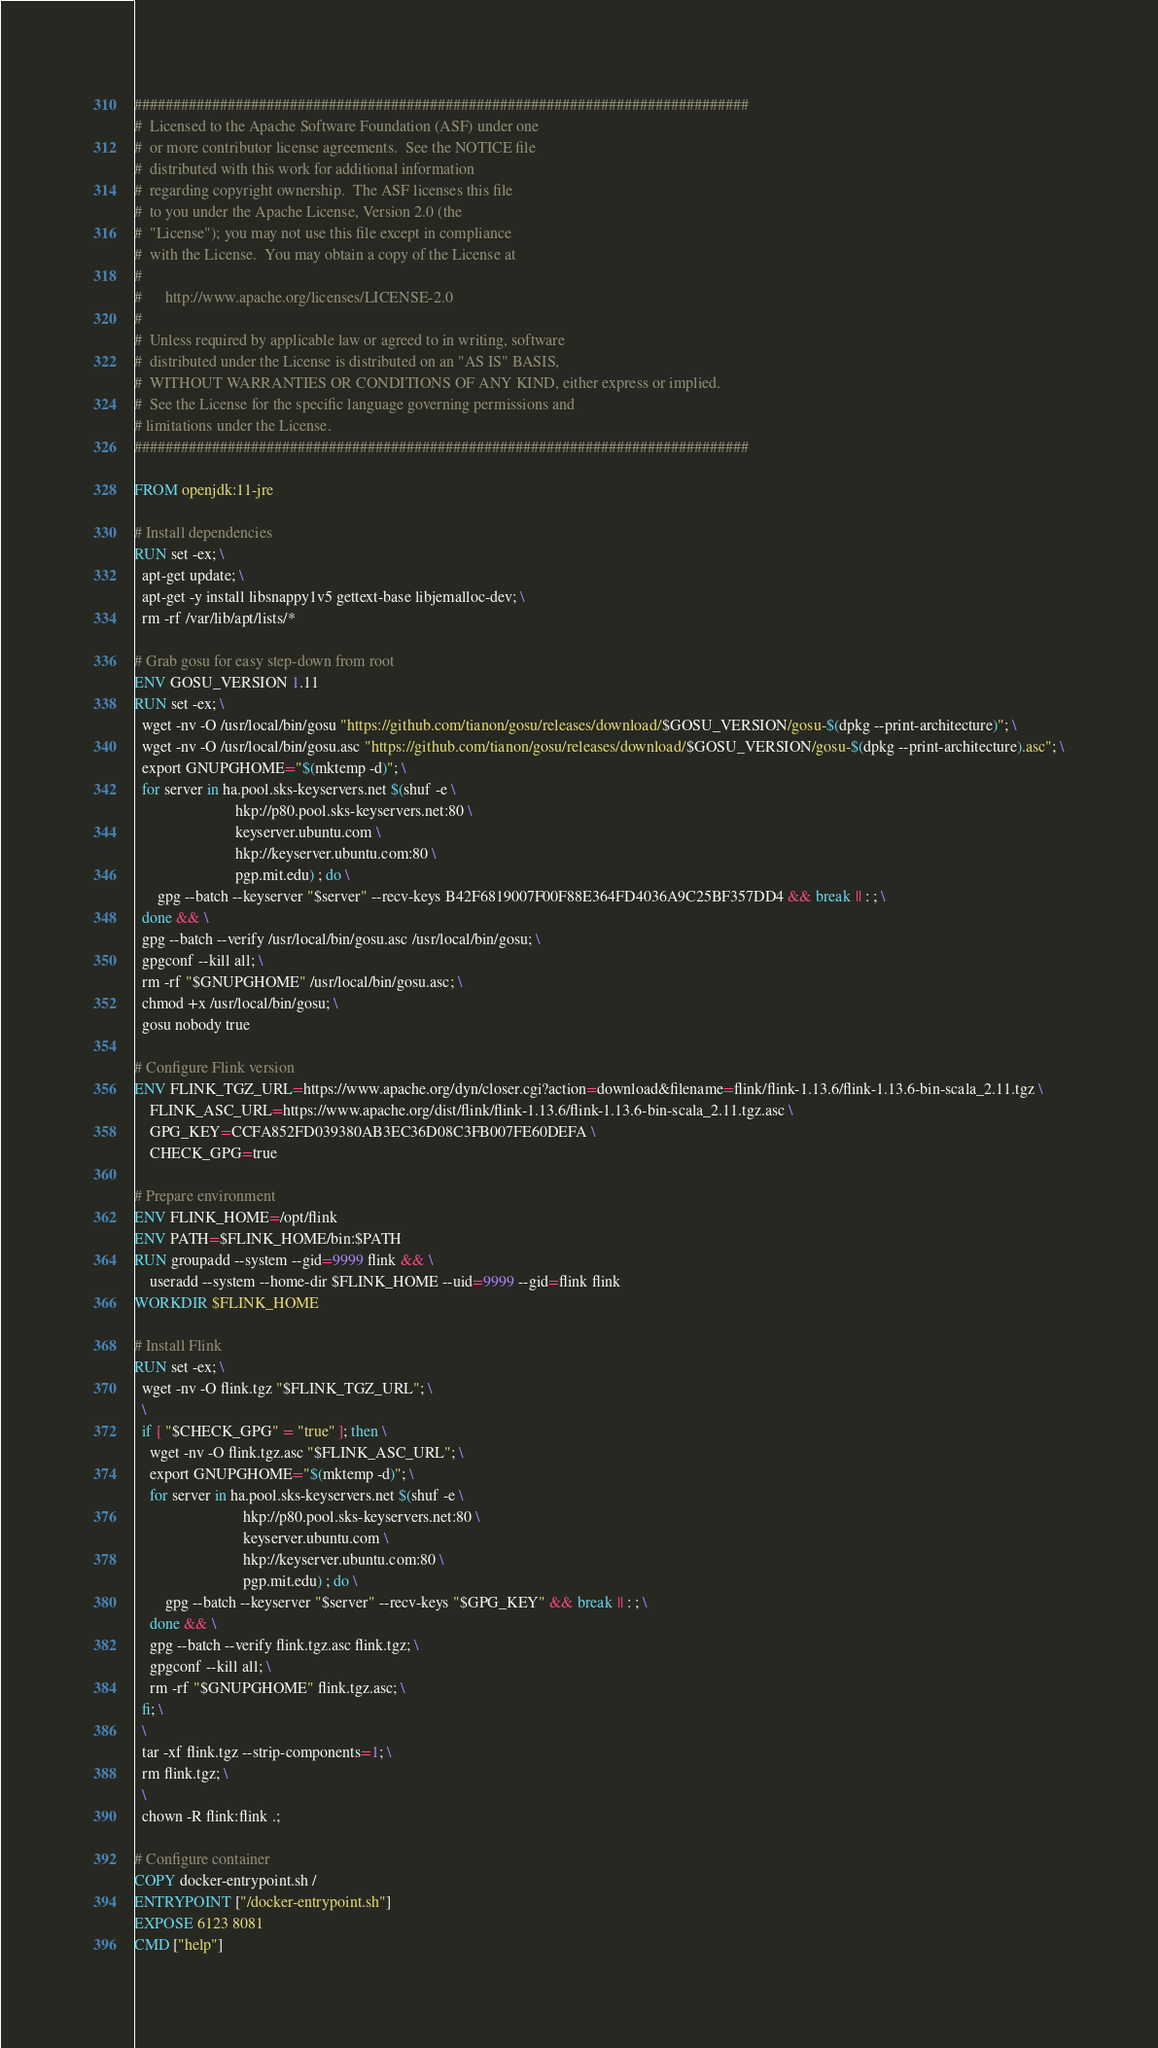<code> <loc_0><loc_0><loc_500><loc_500><_Dockerfile_>###############################################################################
#  Licensed to the Apache Software Foundation (ASF) under one
#  or more contributor license agreements.  See the NOTICE file
#  distributed with this work for additional information
#  regarding copyright ownership.  The ASF licenses this file
#  to you under the Apache License, Version 2.0 (the
#  "License"); you may not use this file except in compliance
#  with the License.  You may obtain a copy of the License at
#
#      http://www.apache.org/licenses/LICENSE-2.0
#
#  Unless required by applicable law or agreed to in writing, software
#  distributed under the License is distributed on an "AS IS" BASIS,
#  WITHOUT WARRANTIES OR CONDITIONS OF ANY KIND, either express or implied.
#  See the License for the specific language governing permissions and
# limitations under the License.
###############################################################################

FROM openjdk:11-jre

# Install dependencies
RUN set -ex; \
  apt-get update; \
  apt-get -y install libsnappy1v5 gettext-base libjemalloc-dev; \
  rm -rf /var/lib/apt/lists/*

# Grab gosu for easy step-down from root
ENV GOSU_VERSION 1.11
RUN set -ex; \
  wget -nv -O /usr/local/bin/gosu "https://github.com/tianon/gosu/releases/download/$GOSU_VERSION/gosu-$(dpkg --print-architecture)"; \
  wget -nv -O /usr/local/bin/gosu.asc "https://github.com/tianon/gosu/releases/download/$GOSU_VERSION/gosu-$(dpkg --print-architecture).asc"; \
  export GNUPGHOME="$(mktemp -d)"; \
  for server in ha.pool.sks-keyservers.net $(shuf -e \
                          hkp://p80.pool.sks-keyservers.net:80 \
                          keyserver.ubuntu.com \
                          hkp://keyserver.ubuntu.com:80 \
                          pgp.mit.edu) ; do \
      gpg --batch --keyserver "$server" --recv-keys B42F6819007F00F88E364FD4036A9C25BF357DD4 && break || : ; \
  done && \
  gpg --batch --verify /usr/local/bin/gosu.asc /usr/local/bin/gosu; \
  gpgconf --kill all; \
  rm -rf "$GNUPGHOME" /usr/local/bin/gosu.asc; \
  chmod +x /usr/local/bin/gosu; \
  gosu nobody true

# Configure Flink version
ENV FLINK_TGZ_URL=https://www.apache.org/dyn/closer.cgi?action=download&filename=flink/flink-1.13.6/flink-1.13.6-bin-scala_2.11.tgz \
    FLINK_ASC_URL=https://www.apache.org/dist/flink/flink-1.13.6/flink-1.13.6-bin-scala_2.11.tgz.asc \
    GPG_KEY=CCFA852FD039380AB3EC36D08C3FB007FE60DEFA \
    CHECK_GPG=true

# Prepare environment
ENV FLINK_HOME=/opt/flink
ENV PATH=$FLINK_HOME/bin:$PATH
RUN groupadd --system --gid=9999 flink && \
    useradd --system --home-dir $FLINK_HOME --uid=9999 --gid=flink flink
WORKDIR $FLINK_HOME

# Install Flink
RUN set -ex; \
  wget -nv -O flink.tgz "$FLINK_TGZ_URL"; \
  \
  if [ "$CHECK_GPG" = "true" ]; then \
    wget -nv -O flink.tgz.asc "$FLINK_ASC_URL"; \
    export GNUPGHOME="$(mktemp -d)"; \
    for server in ha.pool.sks-keyservers.net $(shuf -e \
                            hkp://p80.pool.sks-keyservers.net:80 \
                            keyserver.ubuntu.com \
                            hkp://keyserver.ubuntu.com:80 \
                            pgp.mit.edu) ; do \
        gpg --batch --keyserver "$server" --recv-keys "$GPG_KEY" && break || : ; \
    done && \
    gpg --batch --verify flink.tgz.asc flink.tgz; \
    gpgconf --kill all; \
    rm -rf "$GNUPGHOME" flink.tgz.asc; \
  fi; \
  \
  tar -xf flink.tgz --strip-components=1; \
  rm flink.tgz; \
  \
  chown -R flink:flink .;

# Configure container
COPY docker-entrypoint.sh /
ENTRYPOINT ["/docker-entrypoint.sh"]
EXPOSE 6123 8081
CMD ["help"]
</code> 